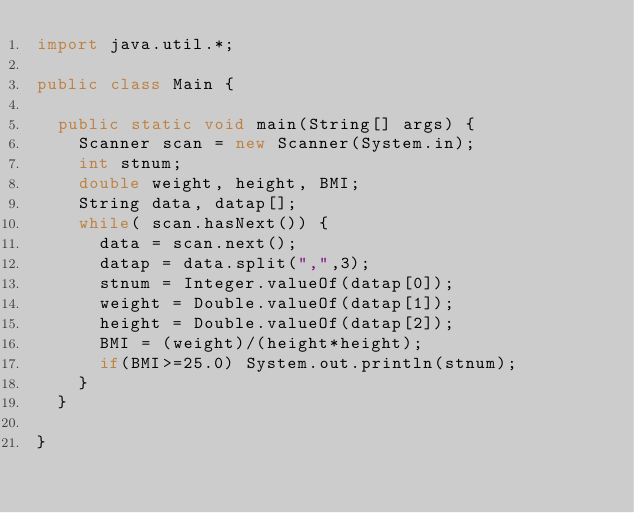Convert code to text. <code><loc_0><loc_0><loc_500><loc_500><_Java_>import java.util.*;

public class Main {

	public static void main(String[] args) {
		Scanner scan = new Scanner(System.in);
		int stnum;
		double weight, height, BMI;
		String data, datap[];
		while( scan.hasNext()) {
			data = scan.next();
			datap = data.split(",",3);
			stnum = Integer.valueOf(datap[0]);
			weight = Double.valueOf(datap[1]);
			height = Double.valueOf(datap[2]);
			BMI = (weight)/(height*height);
			if(BMI>=25.0) System.out.println(stnum);
		}
	}

}</code> 